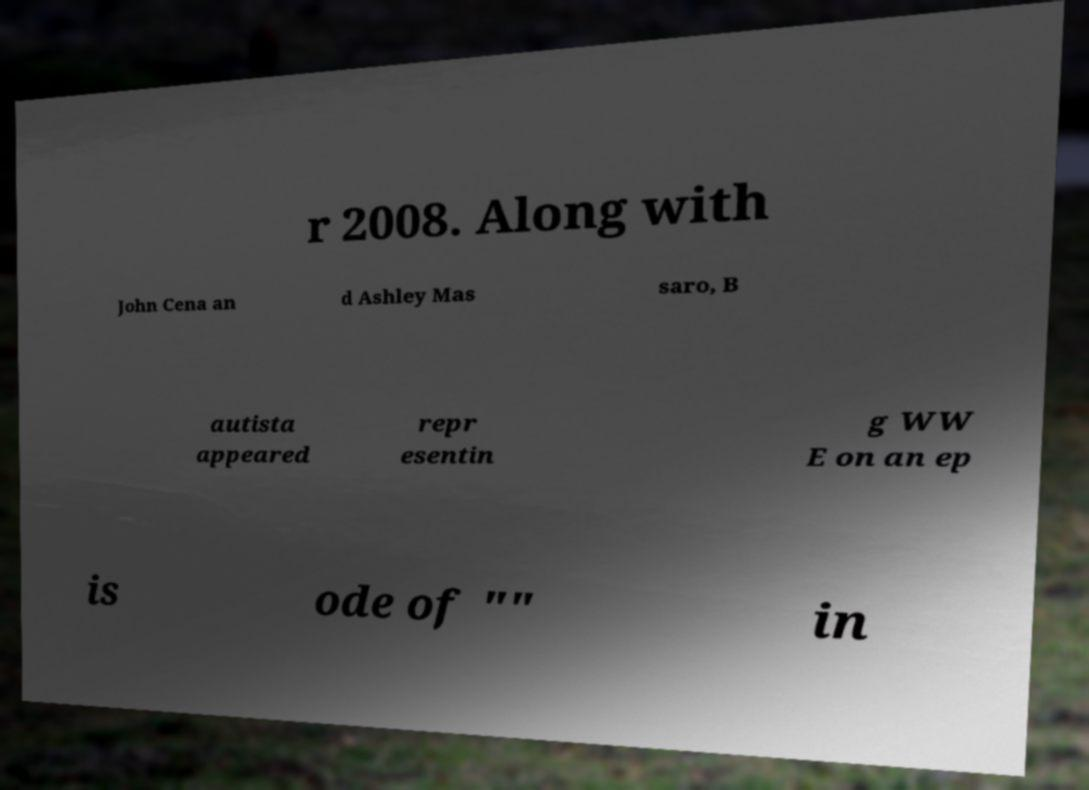I need the written content from this picture converted into text. Can you do that? r 2008. Along with John Cena an d Ashley Mas saro, B autista appeared repr esentin g WW E on an ep is ode of "" in 